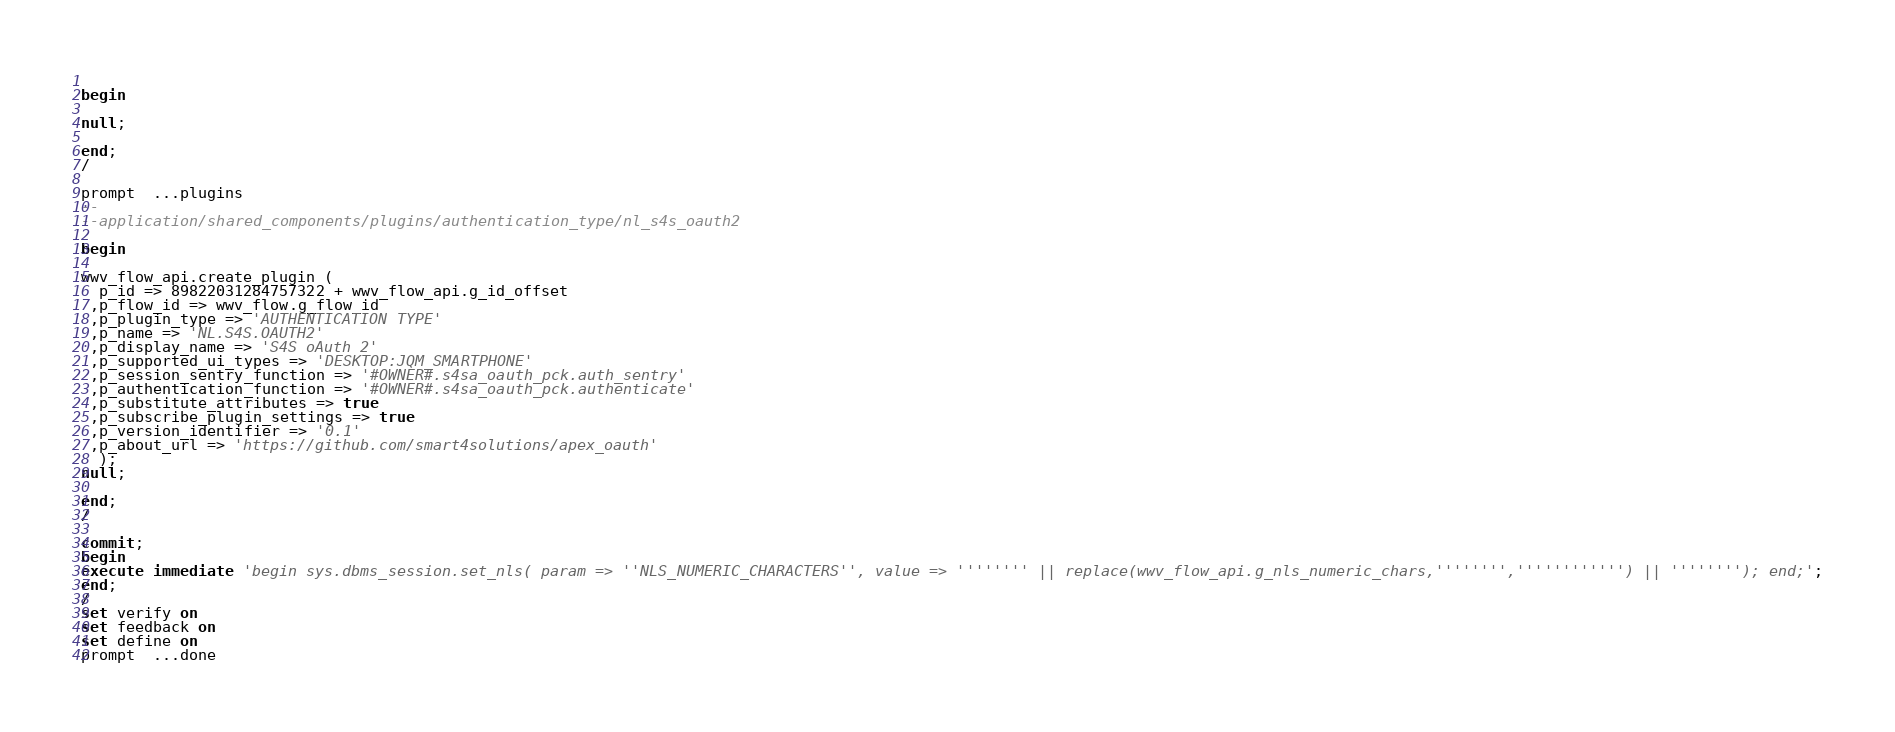<code> <loc_0><loc_0><loc_500><loc_500><_SQL_> 
begin
 
null;
 
end;
/

prompt  ...plugins
--
--application/shared_components/plugins/authentication_type/nl_s4s_oauth2
 
begin
 
wwv_flow_api.create_plugin (
  p_id => 89822031284757322 + wwv_flow_api.g_id_offset
 ,p_flow_id => wwv_flow.g_flow_id
 ,p_plugin_type => 'AUTHENTICATION TYPE'
 ,p_name => 'NL.S4S.OAUTH2'
 ,p_display_name => 'S4S oAuth 2'
 ,p_supported_ui_types => 'DESKTOP:JQM_SMARTPHONE'
 ,p_session_sentry_function => '#OWNER#.s4sa_oauth_pck.auth_sentry'
 ,p_authentication_function => '#OWNER#.s4sa_oauth_pck.authenticate'
 ,p_substitute_attributes => true
 ,p_subscribe_plugin_settings => true
 ,p_version_identifier => '0.1'
 ,p_about_url => 'https://github.com/smart4solutions/apex_oauth'
  );
null;
 
end;
/

commit;
begin
execute immediate 'begin sys.dbms_session.set_nls( param => ''NLS_NUMERIC_CHARACTERS'', value => '''''''' || replace(wwv_flow_api.g_nls_numeric_chars,'''''''','''''''''''') || ''''''''); end;';
end;
/
set verify on
set feedback on
set define on
prompt  ...done
</code> 